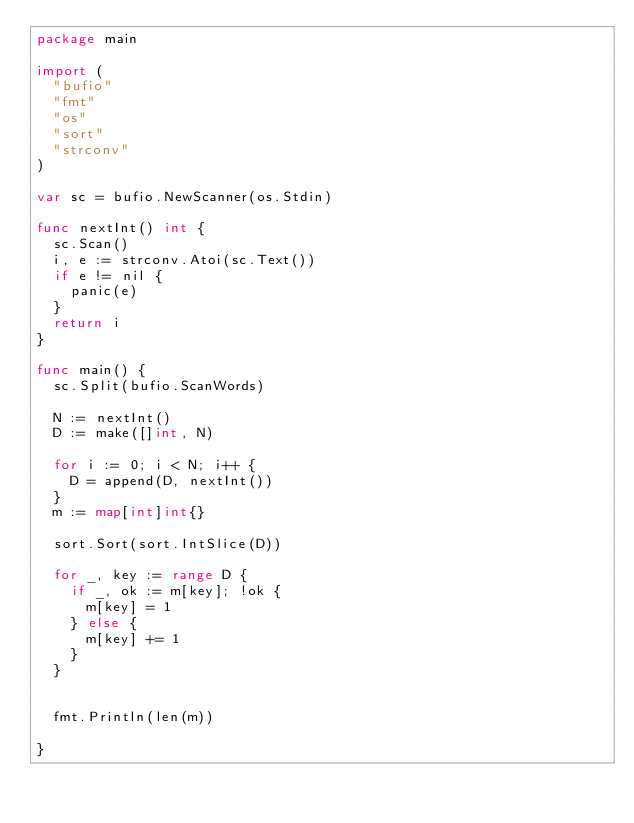<code> <loc_0><loc_0><loc_500><loc_500><_Go_>package main

import (
	"bufio"
	"fmt"
	"os"
	"sort"
	"strconv"
)

var sc = bufio.NewScanner(os.Stdin)

func nextInt() int {
	sc.Scan()
	i, e := strconv.Atoi(sc.Text())
	if e != nil {
		panic(e)
	}
	return i
}

func main() {
	sc.Split(bufio.ScanWords)

	N := nextInt()
	D := make([]int, N)
	
	for i := 0; i < N; i++ {
		D = append(D, nextInt())
	}
	m := map[int]int{}

	sort.Sort(sort.IntSlice(D))

	for _, key := range D {
		if _, ok := m[key]; !ok {
			m[key] = 1
		} else {
			m[key] += 1
		}
	}
	

	fmt.Println(len(m))

}
</code> 